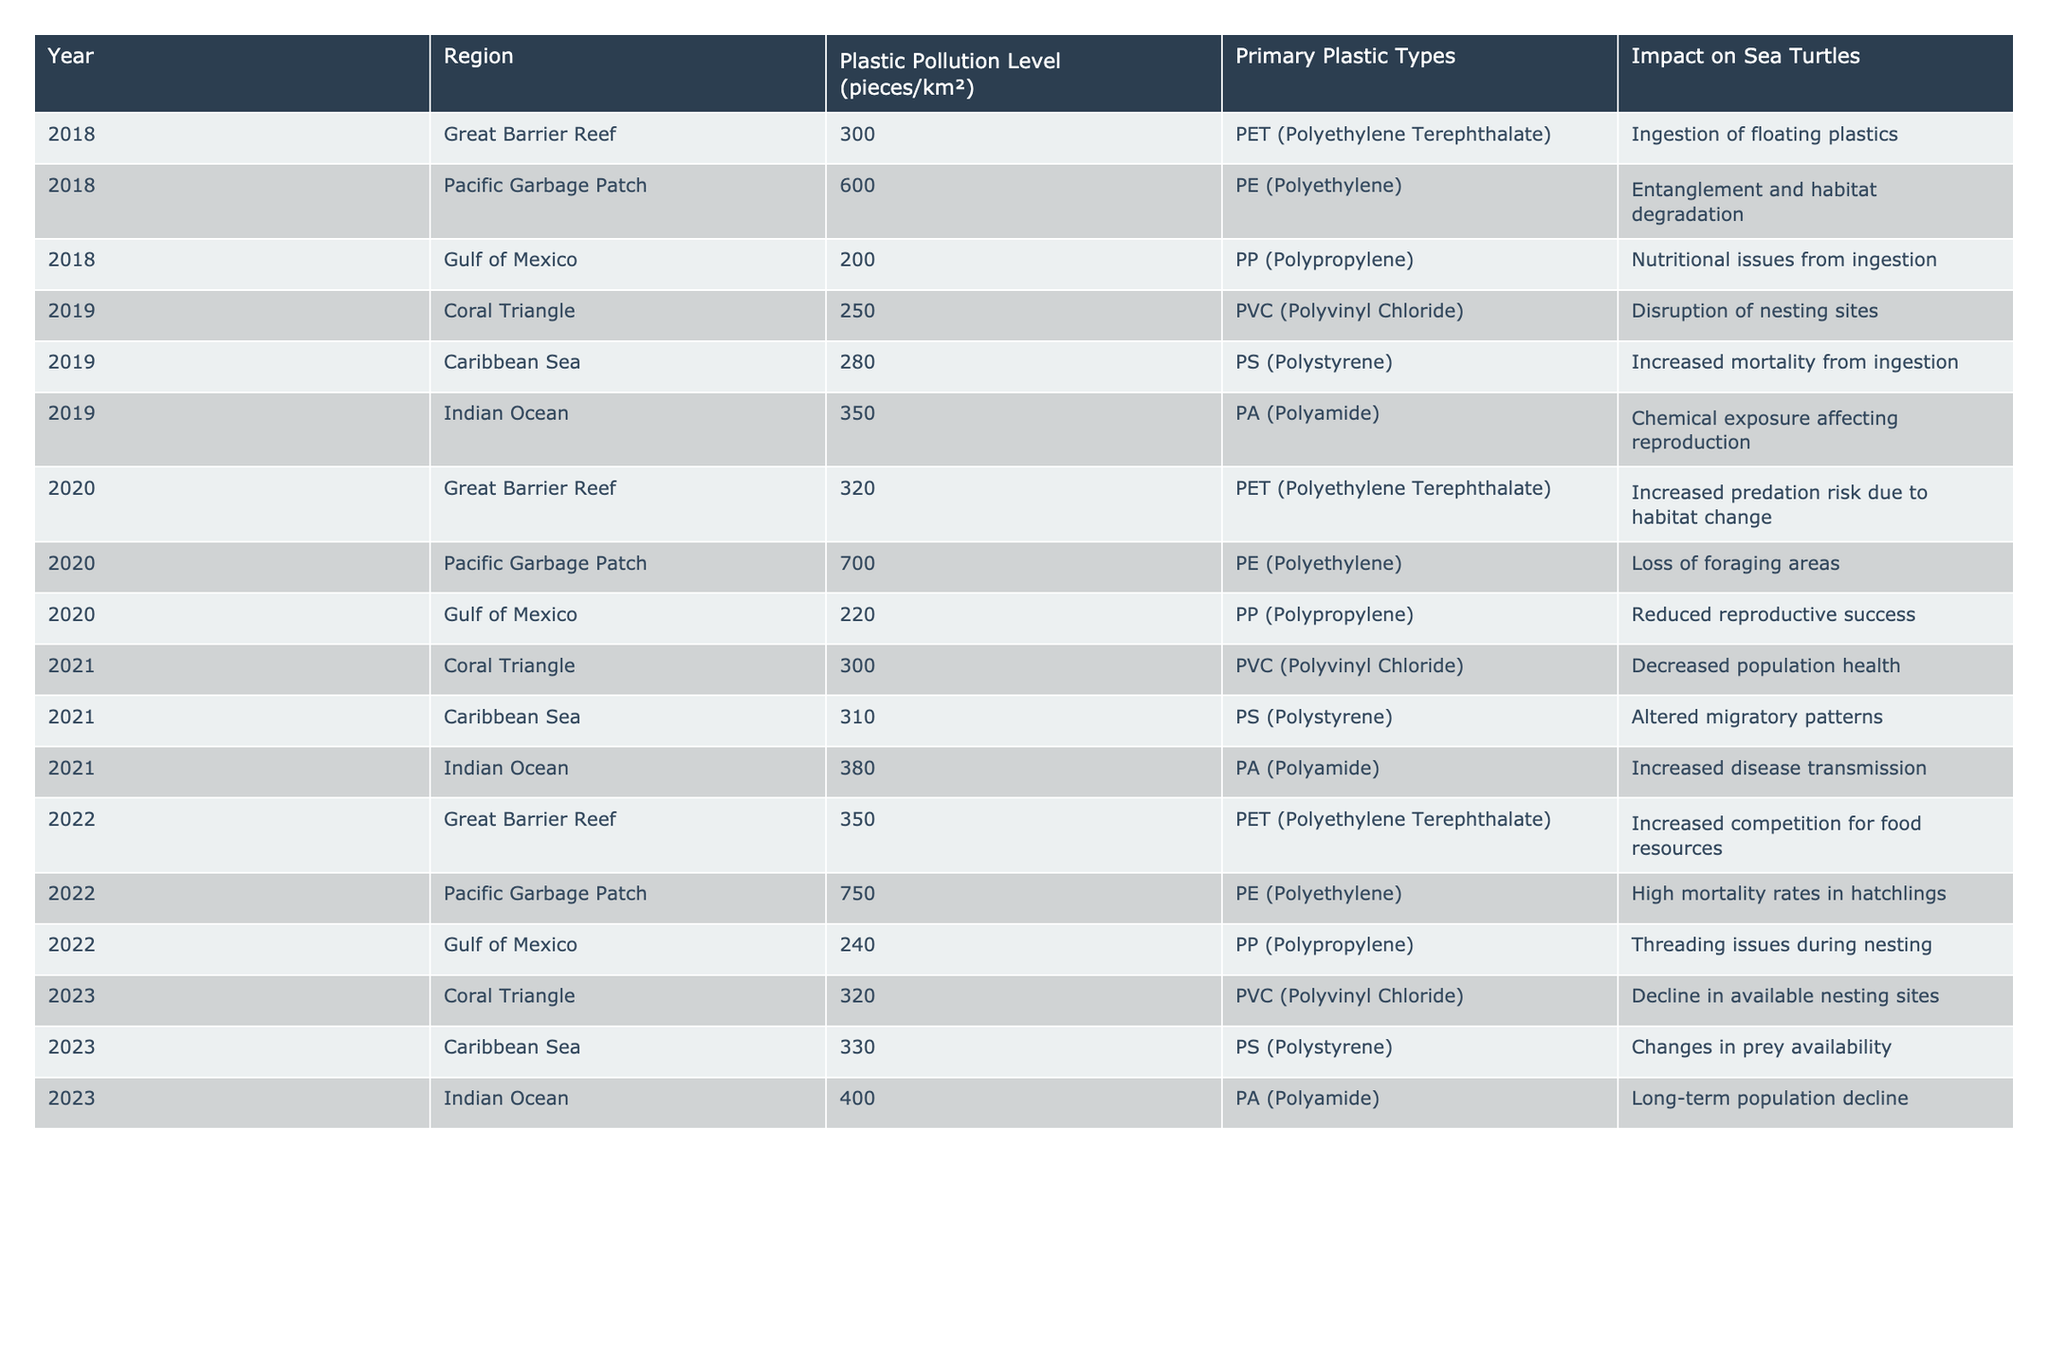What was the highest plastic pollution level recorded in the table? By examining the column for plastic pollution levels, the highest recorded value is 750 pieces/km² in the Pacific Garbage Patch in 2022.
Answer: 750 pieces/km² Which region had the lowest plastic pollution level in 2018? Looking at the plastic pollution levels for each region in 2018, the Gulf of Mexico had the lowest level at 200 pieces/km².
Answer: Gulf of Mexico How many regions reported an increase in plastic pollution levels from 2018 to 2023? By comparing the plastic pollution levels from 2018 to 2023, the Great Barrier Reef, Pacific Garbage Patch, Coral Triangle, Caribbean Sea, and Indian Ocean all increased, totaling five regions.
Answer: 5 regions What is the primary plastic type recorded in the Indian Ocean for the year 2021? By checking the data for the Indian Ocean in 2021, it shows that the primary plastic type was PA (Polyamide).
Answer: PA (Polyamide) Did the Gulf of Mexico's plastic pollution level rise consistently from 2018 to 2023? Evaluating the plastic pollution levels in the Gulf of Mexico across the years shows fluctuations, with levels of 200 in 2018, 220 in 2020, 240 in 2022, and no data for 2019 but 2021 had 240, indicating it does not rise consistently.
Answer: No What was the average plastic pollution level across all regions in 2020? The levels in 2020 are 320, 700, and 220 for the Great Barrier Reef, Pacific Garbage Patch, and Gulf of Mexico, respectively. Adding these gives 320 + 700 + 220 = 1240, and dividing by three regions gives an average of 413.33.
Answer: 413.33 pieces/km² Which year had the highest recorded plastic pollution level in the Coral Triangle? The table shows that in 2021, the Coral Triangle had a plastic pollution level of 300 pieces/km², which is higher than the level of 250 in 2019 and 320 in 2023.
Answer: 2021 Was there any impact on sea turtles associated with the high pollution levels in the Pacific Garbage Patch in 2022? The data indicates that in 2022 the Pacific Garbage Patch had 750 pieces/km² of pollution and a stated impact of high mortality rates in hatchlings, directly associating high pollution with negative effects on turtles.
Answer: Yes List the years when the Caribbean Sea had plastic pollution levels above 300 pieces/km². Looking through the data, the Caribbean Sea registered levels of 310 in 2021 and 330 in 2023, which are both above 300.
Answer: 2021 and 2023 What is the overall trend in plastic pollution levels in the Great Barrier Reef from 2018 to 2022? Analyzing the Great Barrier Reef: 300 in 2018, 320 in 2020, and 350 in 2022 shows a clear increasing trend as the values rise each year.
Answer: Increasing trend How does the impact on sea turtles differ between the Gulf of Mexico in 2019 and 2023? In 2019, the impact was nutritional issues from ingestion, while in 2023 it was threading issues during nesting. This indicates that the nature of consumption-related problems changed over these years.
Answer: Different impacts 